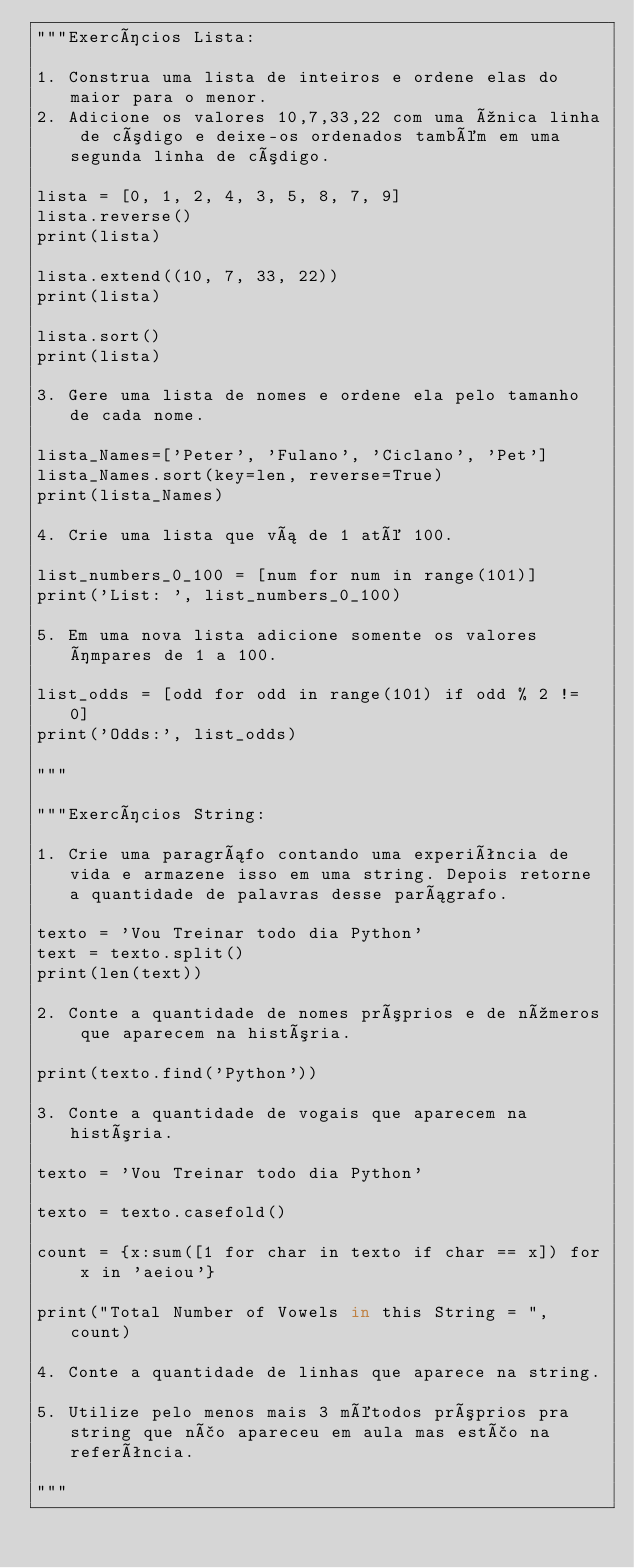Convert code to text. <code><loc_0><loc_0><loc_500><loc_500><_Python_>"""Exercícios Lista:

1. Construa uma lista de inteiros e ordene elas do maior para o menor.
2. Adicione os valores 10,7,33,22 com uma única linha de código e deixe-os ordenados também em uma segunda linha de código.

lista = [0, 1, 2, 4, 3, 5, 8, 7, 9]
lista.reverse()
print(lista)

lista.extend((10, 7, 33, 22))
print(lista)

lista.sort()
print(lista)

3. Gere uma lista de nomes e ordene ela pelo tamanho de cada nome.

lista_Names=['Peter', 'Fulano', 'Ciclano', 'Pet']
lista_Names.sort(key=len, reverse=True)
print(lista_Names)

4. Crie uma lista que vá de 1 até 100.

list_numbers_0_100 = [num for num in range(101)]
print('List: ', list_numbers_0_100)

5. Em uma nova lista adicione somente os valores ímpares de 1 a 100.

list_odds = [odd for odd in range(101) if odd % 2 != 0]
print('Odds:', list_odds)

"""

"""Exercícios String:

1. Crie uma paragráfo contando uma experiência de vida e armazene isso em uma string. Depois retorne a quantidade de palavras desse parágrafo.

texto = 'Vou Treinar todo dia Python'
text = texto.split()
print(len(text))

2. Conte a quantidade de nomes próprios e de números que aparecem na história.

print(texto.find('Python'))

3. Conte a quantidade de vogais que aparecem na história.

texto = 'Vou Treinar todo dia Python'

texto = texto.casefold()

count = {x:sum([1 for char in texto if char == x]) for x in 'aeiou'}
 
print("Total Number of Vowels in this String = ", count)

4. Conte a quantidade de linhas que aparece na string.

5. Utilize pelo menos mais 3 métodos próprios pra string que não apareceu em aula mas estão na referência.

"""</code> 